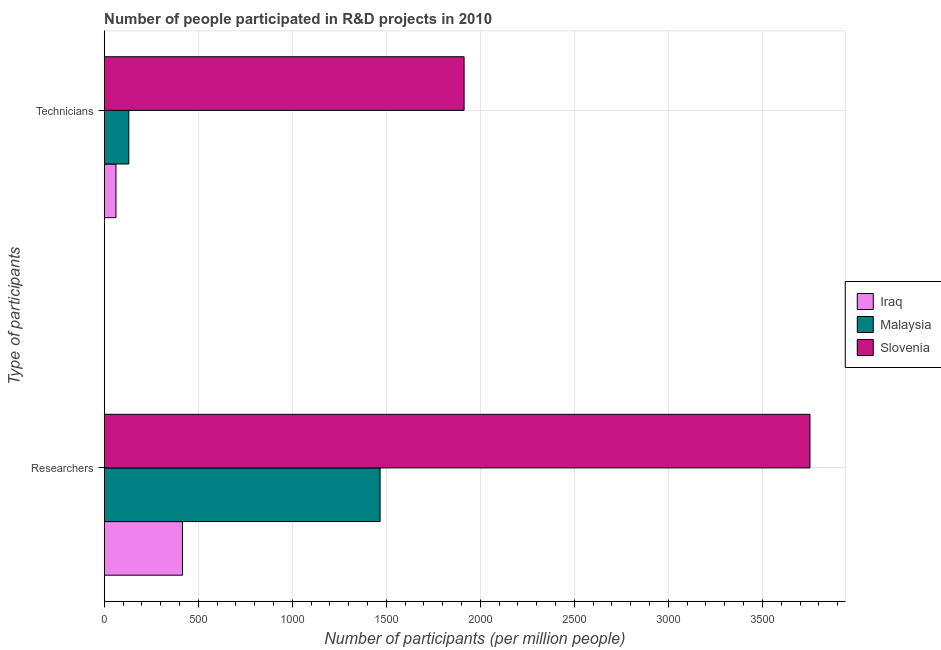How many groups of bars are there?
Your answer should be very brief. 2. What is the label of the 2nd group of bars from the top?
Offer a very short reply. Researchers. What is the number of researchers in Malaysia?
Provide a succinct answer. 1467.07. Across all countries, what is the maximum number of technicians?
Your answer should be very brief. 1913.78. Across all countries, what is the minimum number of researchers?
Offer a very short reply. 416.25. In which country was the number of researchers maximum?
Give a very brief answer. Slovenia. In which country was the number of technicians minimum?
Ensure brevity in your answer.  Iraq. What is the total number of researchers in the graph?
Make the answer very short. 5636.35. What is the difference between the number of technicians in Slovenia and that in Malaysia?
Your answer should be very brief. 1783.07. What is the difference between the number of technicians in Malaysia and the number of researchers in Iraq?
Your answer should be compact. -285.54. What is the average number of researchers per country?
Keep it short and to the point. 1878.78. What is the difference between the number of researchers and number of technicians in Slovenia?
Make the answer very short. 1839.24. In how many countries, is the number of technicians greater than 2300 ?
Provide a succinct answer. 0. What is the ratio of the number of technicians in Iraq to that in Malaysia?
Your answer should be compact. 0.48. Is the number of technicians in Slovenia less than that in Iraq?
Provide a succinct answer. No. In how many countries, is the number of researchers greater than the average number of researchers taken over all countries?
Provide a short and direct response. 1. What does the 1st bar from the top in Researchers represents?
Keep it short and to the point. Slovenia. What does the 2nd bar from the bottom in Technicians represents?
Your answer should be compact. Malaysia. How many bars are there?
Your response must be concise. 6. Are all the bars in the graph horizontal?
Offer a very short reply. Yes. Are the values on the major ticks of X-axis written in scientific E-notation?
Your response must be concise. No. Where does the legend appear in the graph?
Make the answer very short. Center right. How many legend labels are there?
Give a very brief answer. 3. What is the title of the graph?
Keep it short and to the point. Number of people participated in R&D projects in 2010. What is the label or title of the X-axis?
Provide a short and direct response. Number of participants (per million people). What is the label or title of the Y-axis?
Your answer should be very brief. Type of participants. What is the Number of participants (per million people) of Iraq in Researchers?
Your response must be concise. 416.25. What is the Number of participants (per million people) of Malaysia in Researchers?
Keep it short and to the point. 1467.07. What is the Number of participants (per million people) in Slovenia in Researchers?
Keep it short and to the point. 3753.02. What is the Number of participants (per million people) in Iraq in Technicians?
Ensure brevity in your answer.  62.43. What is the Number of participants (per million people) in Malaysia in Technicians?
Your answer should be very brief. 130.71. What is the Number of participants (per million people) in Slovenia in Technicians?
Ensure brevity in your answer.  1913.78. Across all Type of participants, what is the maximum Number of participants (per million people) in Iraq?
Ensure brevity in your answer.  416.25. Across all Type of participants, what is the maximum Number of participants (per million people) of Malaysia?
Ensure brevity in your answer.  1467.07. Across all Type of participants, what is the maximum Number of participants (per million people) in Slovenia?
Ensure brevity in your answer.  3753.02. Across all Type of participants, what is the minimum Number of participants (per million people) of Iraq?
Your response must be concise. 62.43. Across all Type of participants, what is the minimum Number of participants (per million people) in Malaysia?
Ensure brevity in your answer.  130.71. Across all Type of participants, what is the minimum Number of participants (per million people) in Slovenia?
Give a very brief answer. 1913.78. What is the total Number of participants (per million people) of Iraq in the graph?
Your response must be concise. 478.68. What is the total Number of participants (per million people) in Malaysia in the graph?
Your response must be concise. 1597.79. What is the total Number of participants (per million people) in Slovenia in the graph?
Provide a short and direct response. 5666.8. What is the difference between the Number of participants (per million people) of Iraq in Researchers and that in Technicians?
Keep it short and to the point. 353.83. What is the difference between the Number of participants (per million people) in Malaysia in Researchers and that in Technicians?
Ensure brevity in your answer.  1336.36. What is the difference between the Number of participants (per million people) of Slovenia in Researchers and that in Technicians?
Your response must be concise. 1839.24. What is the difference between the Number of participants (per million people) of Iraq in Researchers and the Number of participants (per million people) of Malaysia in Technicians?
Keep it short and to the point. 285.54. What is the difference between the Number of participants (per million people) of Iraq in Researchers and the Number of participants (per million people) of Slovenia in Technicians?
Provide a short and direct response. -1497.53. What is the difference between the Number of participants (per million people) of Malaysia in Researchers and the Number of participants (per million people) of Slovenia in Technicians?
Offer a terse response. -446.71. What is the average Number of participants (per million people) of Iraq per Type of participants?
Keep it short and to the point. 239.34. What is the average Number of participants (per million people) in Malaysia per Type of participants?
Provide a succinct answer. 798.89. What is the average Number of participants (per million people) of Slovenia per Type of participants?
Provide a succinct answer. 2833.4. What is the difference between the Number of participants (per million people) of Iraq and Number of participants (per million people) of Malaysia in Researchers?
Offer a terse response. -1050.82. What is the difference between the Number of participants (per million people) of Iraq and Number of participants (per million people) of Slovenia in Researchers?
Ensure brevity in your answer.  -3336.77. What is the difference between the Number of participants (per million people) in Malaysia and Number of participants (per million people) in Slovenia in Researchers?
Your answer should be compact. -2285.95. What is the difference between the Number of participants (per million people) of Iraq and Number of participants (per million people) of Malaysia in Technicians?
Your answer should be compact. -68.29. What is the difference between the Number of participants (per million people) in Iraq and Number of participants (per million people) in Slovenia in Technicians?
Provide a short and direct response. -1851.36. What is the difference between the Number of participants (per million people) of Malaysia and Number of participants (per million people) of Slovenia in Technicians?
Ensure brevity in your answer.  -1783.07. What is the ratio of the Number of participants (per million people) in Iraq in Researchers to that in Technicians?
Provide a succinct answer. 6.67. What is the ratio of the Number of participants (per million people) in Malaysia in Researchers to that in Technicians?
Your answer should be very brief. 11.22. What is the ratio of the Number of participants (per million people) in Slovenia in Researchers to that in Technicians?
Provide a short and direct response. 1.96. What is the difference between the highest and the second highest Number of participants (per million people) of Iraq?
Your answer should be compact. 353.83. What is the difference between the highest and the second highest Number of participants (per million people) in Malaysia?
Provide a succinct answer. 1336.36. What is the difference between the highest and the second highest Number of participants (per million people) in Slovenia?
Your response must be concise. 1839.24. What is the difference between the highest and the lowest Number of participants (per million people) of Iraq?
Provide a succinct answer. 353.83. What is the difference between the highest and the lowest Number of participants (per million people) of Malaysia?
Offer a terse response. 1336.36. What is the difference between the highest and the lowest Number of participants (per million people) in Slovenia?
Keep it short and to the point. 1839.24. 